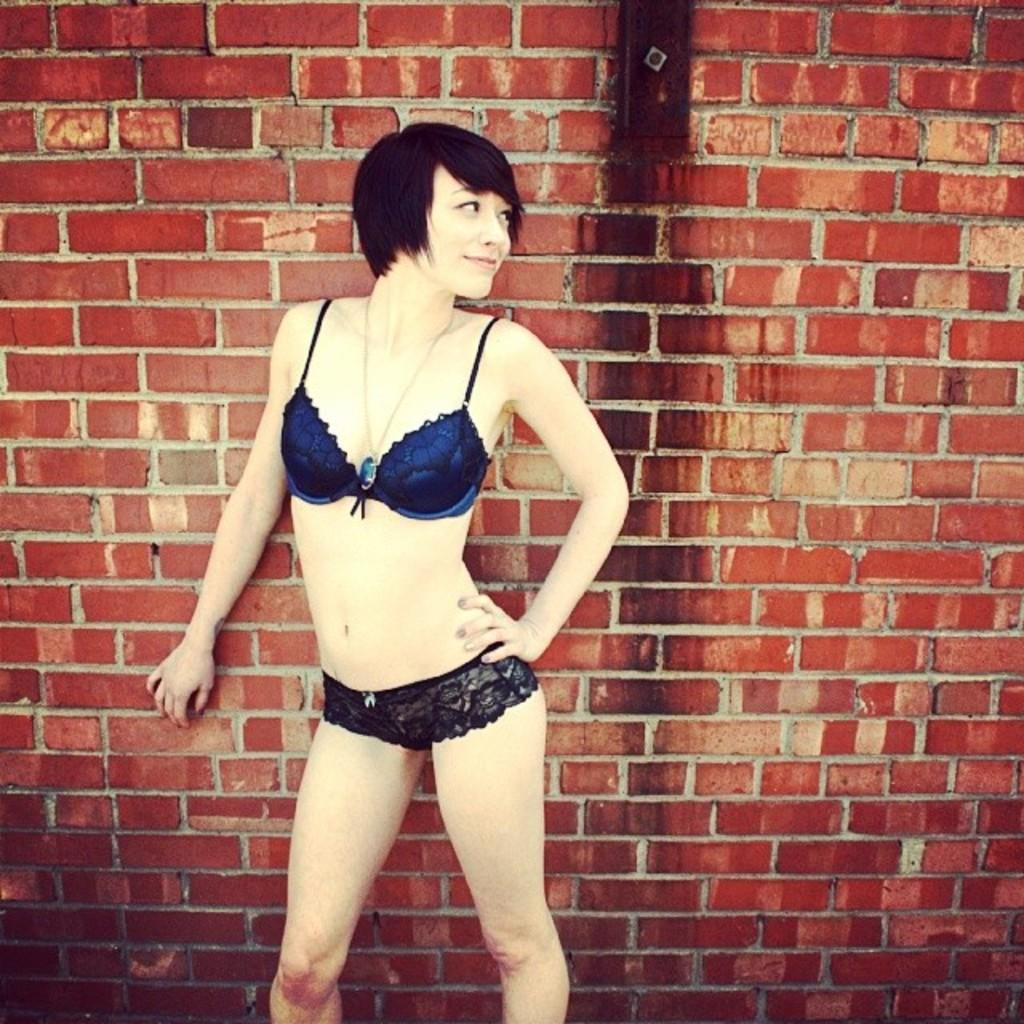What is the main subject of the image? There is a woman standing in the image. What can be seen in the background of the image? There is a brick wall in the background of the image. How many teeth can be seen in the image? There are no teeth visible in the image, as it features a woman standing in front of a brick wall. What type of shoe is the woman wearing in the image? The image does not show the woman's shoes, so it cannot be determined what type of shoe she might be wearing. 